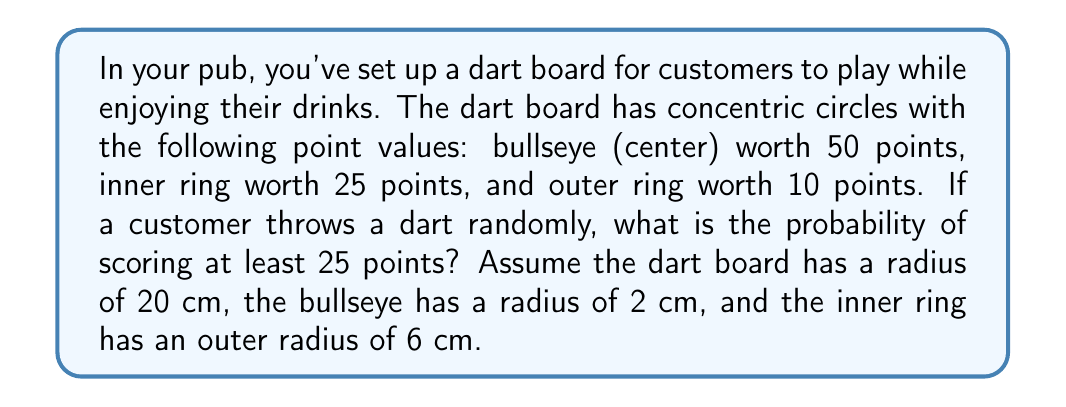Solve this math problem. To solve this problem, we need to calculate the areas of the different scoring regions and compare them to the total area of the dart board. We'll use the formula for the area of a circle: $A = \pi r^2$.

1. Calculate the areas:
   - Total dart board area: $A_t = \pi (20\text{ cm})^2 = 400\pi \text{ cm}^2$
   - Bullseye area: $A_b = \pi (2\text{ cm})^2 = 4\pi \text{ cm}^2$
   - Inner ring area: $A_i = \pi (6\text{ cm})^2 - \pi (2\text{ cm})^2 = 32\pi \text{ cm}^2$

2. The area where a dart will score at least 25 points is the sum of the bullseye and inner ring areas:
   $A_{25+} = A_b + A_i = 4\pi \text{ cm}^2 + 32\pi \text{ cm}^2 = 36\pi \text{ cm}^2$

3. The probability of scoring at least 25 points is the ratio of the area where a dart scores at least 25 points to the total area of the dart board:

   $$P(\text{score} \geq 25) = \frac{A_{25+}}{A_t} = \frac{36\pi \text{ cm}^2}{400\pi \text{ cm}^2} = \frac{36}{400} = 0.09$$

Therefore, the probability of scoring at least 25 points when throwing a dart randomly is 0.09 or 9%.
Answer: 0.09 or 9% 